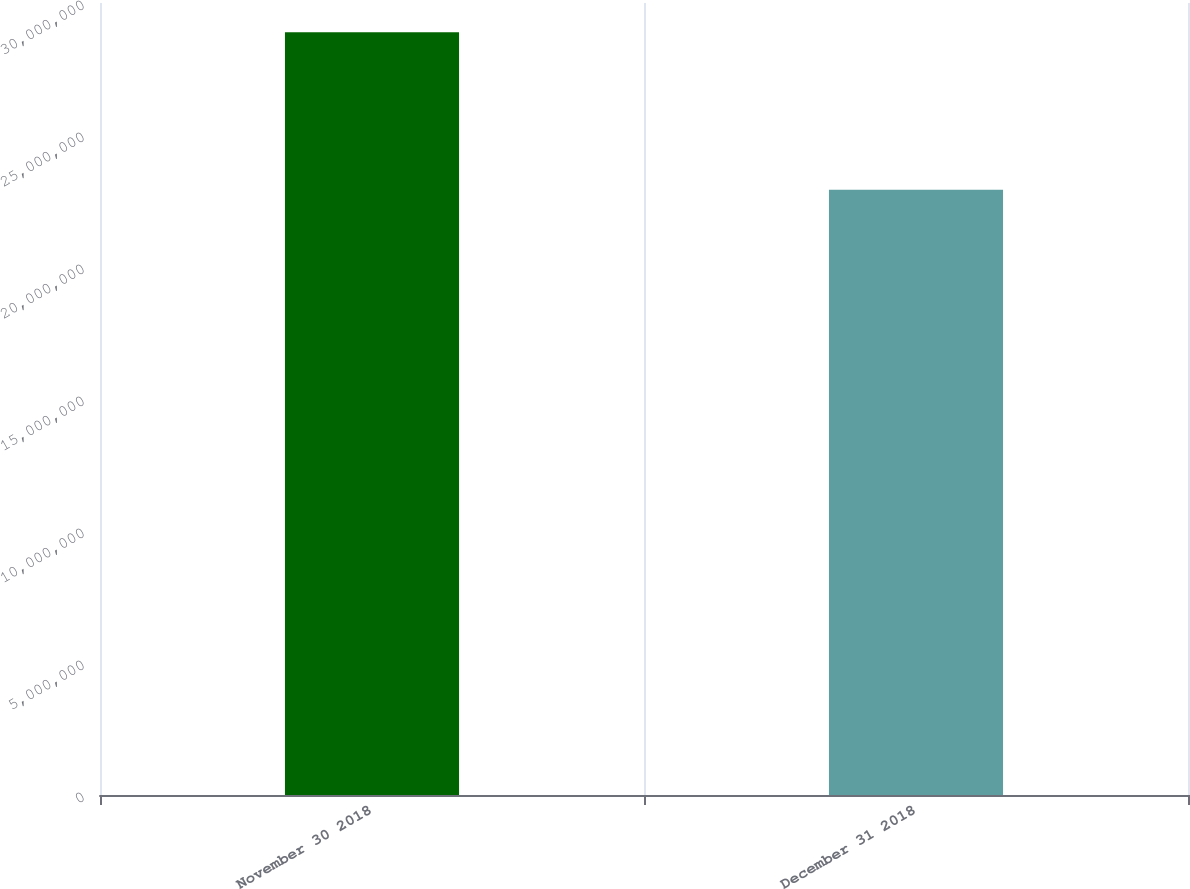Convert chart. <chart><loc_0><loc_0><loc_500><loc_500><bar_chart><fcel>November 30 2018<fcel>December 31 2018<nl><fcel>2.88932e+07<fcel>2.293e+07<nl></chart> 